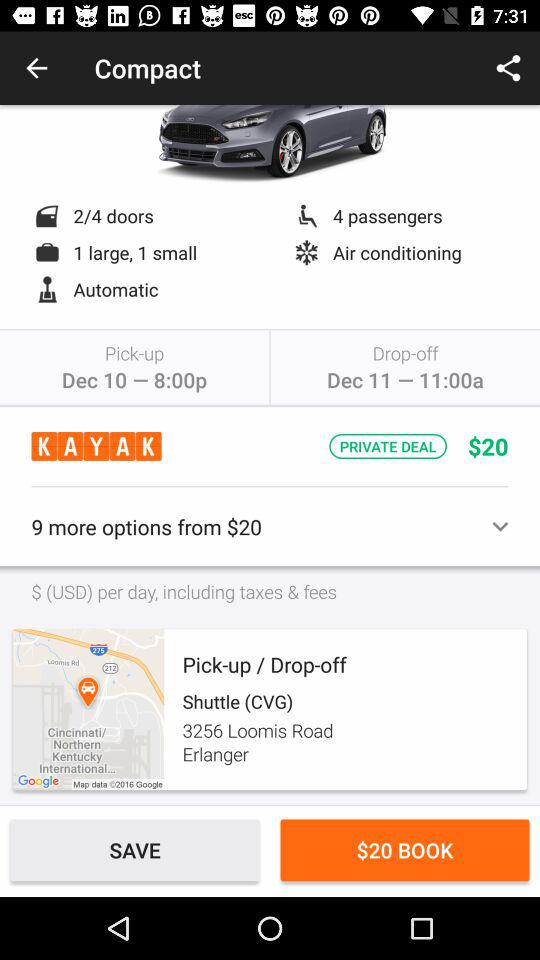How many passengers are booked for the cab? There are 4 passengers booked for the cab. 